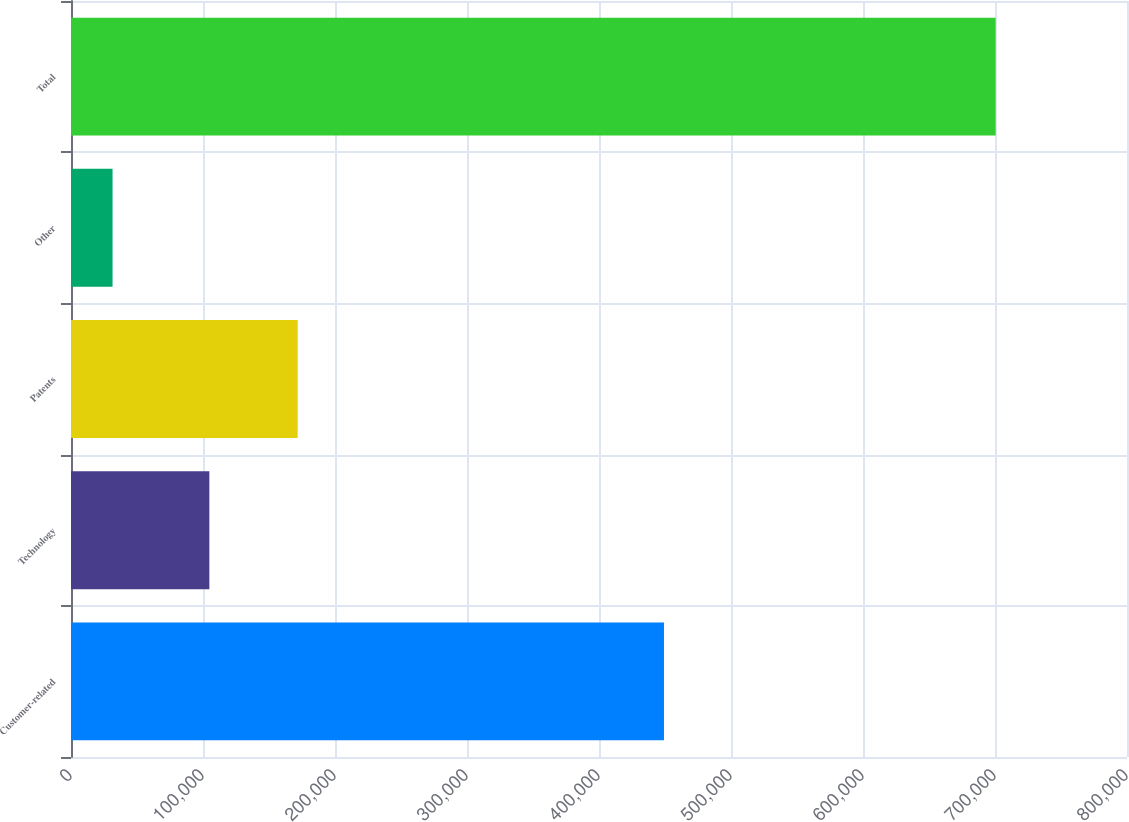<chart> <loc_0><loc_0><loc_500><loc_500><bar_chart><fcel>Customer-related<fcel>Technology<fcel>Patents<fcel>Other<fcel>Total<nl><fcel>449219<fcel>104824<fcel>171726<fcel>31480<fcel>700502<nl></chart> 